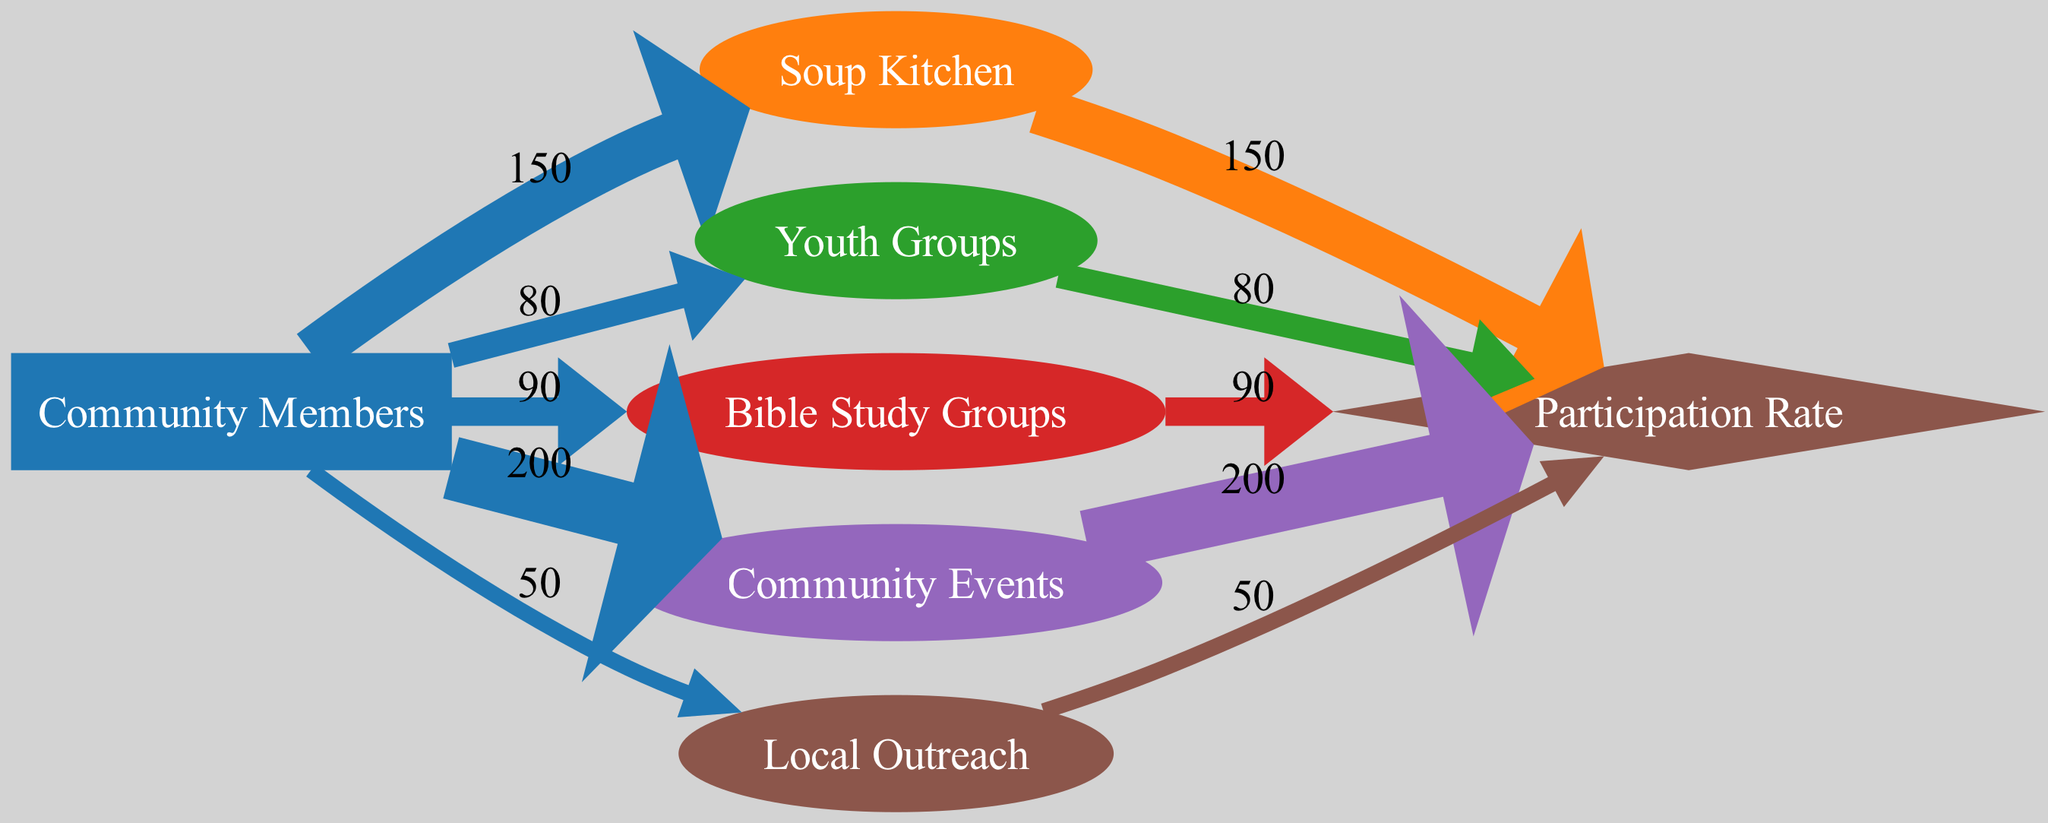What is the participation rate for the Soup Kitchen? The diagram shows a direct link from the Soup Kitchen to the Participation Rate with a value of 150. Therefore, this is the participation rate specific to the Soup Kitchen program.
Answer: 150 How many community members participated in Community Events? There is a direct link from Community Members to Community Events, displaying a value of 200, which indicates the number of community members who participated in this program.
Answer: 200 Which program had the highest number of participants? By comparing the participation values from each program, Community Events has the highest participation value of 200, more than any other program's values.
Answer: Community Events What is the total number of community members participating in all programs? To find the total, we sum the values from each link where Community Members connect to the programs: 150 (Soup Kitchen) + 80 (Youth Groups) + 90 (Bible Study Groups) + 200 (Community Events) + 50 (Local Outreach) = 570.
Answer: 570 How many programs are listed in the diagram? The diagram includes a total of five distinct programs: Soup Kitchen, Youth Groups, Bible Study Groups, Community Events, and Local Outreach. Counting these gives us five programs.
Answer: 5 Which program had the lowest number of participations? The diagram shows the participation value for Local Outreach is 50, which is lower than the other participation values for programs listed (Soup Kitchen, Youth Groups, Bible Study Groups, Community Events).
Answer: Local Outreach How does the number of participants in Youth Groups compare to Bible Study Groups? Youth Groups have a participation value of 80, whereas Bible Study Groups have a value of 90. Comparing these two values shows that Bible Study Groups have more participants than Youth Groups.
Answer: Bible Study Groups What percentage of participants in Local Outreach contributed to the total participation rate? The total participation rate is 570. The contribution from Local Outreach is 50. To calculate the percentage: (50 / 570) * 100 ≈ 8.77%, which indicates a participation contribution of about 8.77%.
Answer: 8.77% 